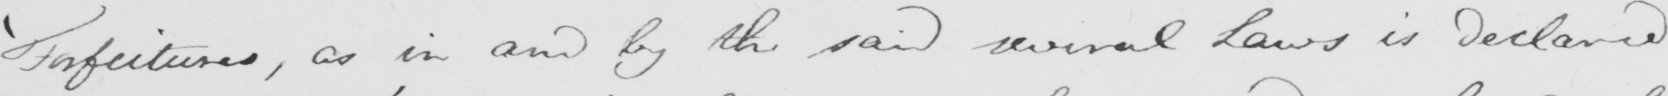Please transcribe the handwritten text in this image. ' Forfeitures , as in and by the said several Laws in declared 